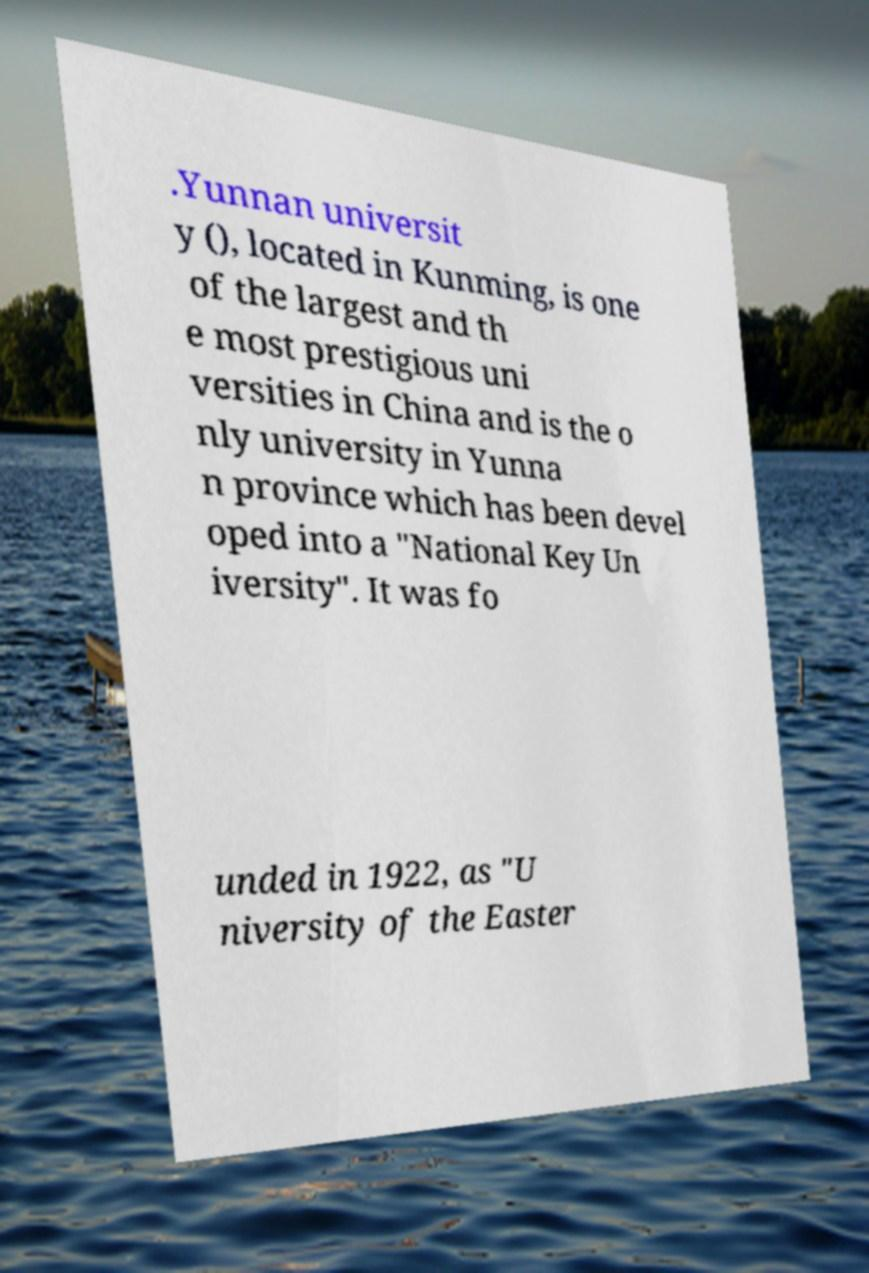What messages or text are displayed in this image? I need them in a readable, typed format. .Yunnan universit y (), located in Kunming, is one of the largest and th e most prestigious uni versities in China and is the o nly university in Yunna n province which has been devel oped into a "National Key Un iversity". It was fo unded in 1922, as "U niversity of the Easter 